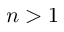Convert formula to latex. <formula><loc_0><loc_0><loc_500><loc_500>n > 1</formula> 